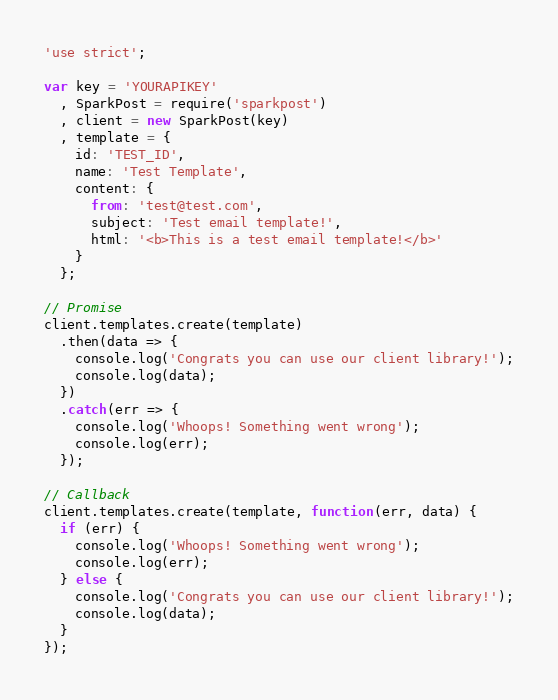Convert code to text. <code><loc_0><loc_0><loc_500><loc_500><_JavaScript_>'use strict';

var key = 'YOURAPIKEY'
  , SparkPost = require('sparkpost')
  , client = new SparkPost(key)
  , template = {
    id: 'TEST_ID',
    name: 'Test Template',
    content: {
      from: 'test@test.com',
      subject: 'Test email template!',
      html: '<b>This is a test email template!</b>'
    }
  };

// Promise
client.templates.create(template)
  .then(data => {
    console.log('Congrats you can use our client library!');
    console.log(data);
  })
  .catch(err => {
    console.log('Whoops! Something went wrong');
    console.log(err);
  });

// Callback
client.templates.create(template, function(err, data) {
  if (err) {
    console.log('Whoops! Something went wrong');
    console.log(err);
  } else {
    console.log('Congrats you can use our client library!');
    console.log(data);
  }
});
</code> 